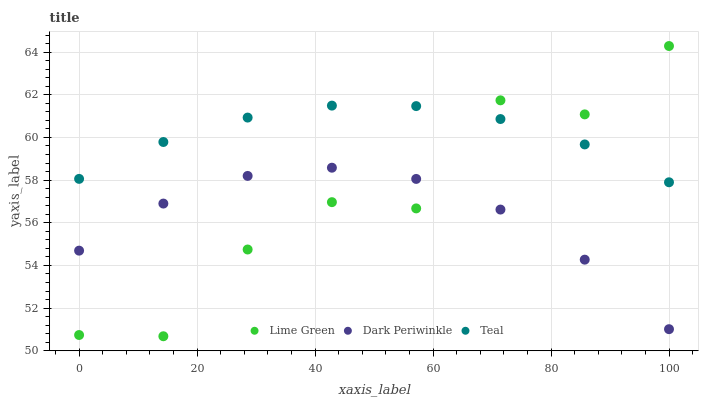Does Dark Periwinkle have the minimum area under the curve?
Answer yes or no. Yes. Does Teal have the maximum area under the curve?
Answer yes or no. Yes. Does Teal have the minimum area under the curve?
Answer yes or no. No. Does Dark Periwinkle have the maximum area under the curve?
Answer yes or no. No. Is Teal the smoothest?
Answer yes or no. Yes. Is Lime Green the roughest?
Answer yes or no. Yes. Is Dark Periwinkle the smoothest?
Answer yes or no. No. Is Dark Periwinkle the roughest?
Answer yes or no. No. Does Lime Green have the lowest value?
Answer yes or no. Yes. Does Dark Periwinkle have the lowest value?
Answer yes or no. No. Does Lime Green have the highest value?
Answer yes or no. Yes. Does Teal have the highest value?
Answer yes or no. No. Is Dark Periwinkle less than Teal?
Answer yes or no. Yes. Is Teal greater than Dark Periwinkle?
Answer yes or no. Yes. Does Dark Periwinkle intersect Lime Green?
Answer yes or no. Yes. Is Dark Periwinkle less than Lime Green?
Answer yes or no. No. Is Dark Periwinkle greater than Lime Green?
Answer yes or no. No. Does Dark Periwinkle intersect Teal?
Answer yes or no. No. 